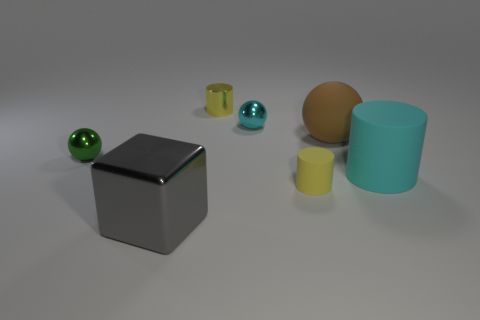Is the small cylinder in front of the big cyan rubber thing made of the same material as the tiny yellow thing behind the big brown object? The small cylinder in front of the large cyan object appears to have a metallic shine, suggesting it is made of metal, whereas the tiny yellow object behind the large brown sphere has a matte finish, which indicates it might be made of a different material, such as plastic or ceramic. Based on their different appearances, they are likely not made of the same material. 